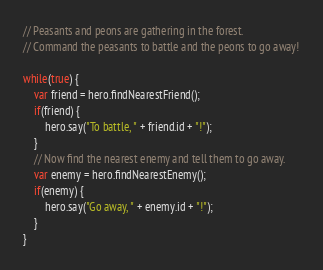Convert code to text. <code><loc_0><loc_0><loc_500><loc_500><_JavaScript_>// Peasants and peons are gathering in the forest.
// Command the peasants to battle and the peons to go away!

while(true) {
    var friend = hero.findNearestFriend();
    if(friend) {
        hero.say("To battle, " + friend.id + "!");
    }
    // Now find the nearest enemy and tell them to go away.
    var enemy = hero.findNearestEnemy();
    if(enemy) {
        hero.say("Go away, " + enemy.id + "!");
    }
}
</code> 